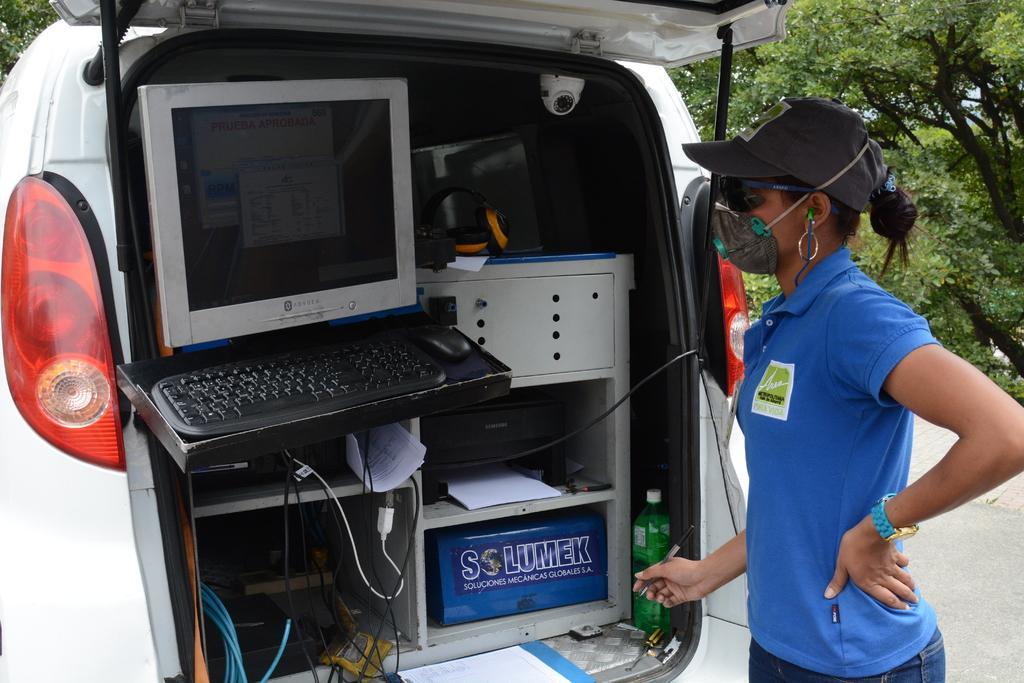In one or two sentences, can you explain what this image depicts? In this image there is a vehicle. The boot of the vehicle is open. Inside the vehicle there are tables, papers, boxes, cable wires, a computer, headphones and a bottle. Beside the vehicle there is a woman standing. She is holding a pen in her hand. She is wearing a mask. In the background there are trees. 